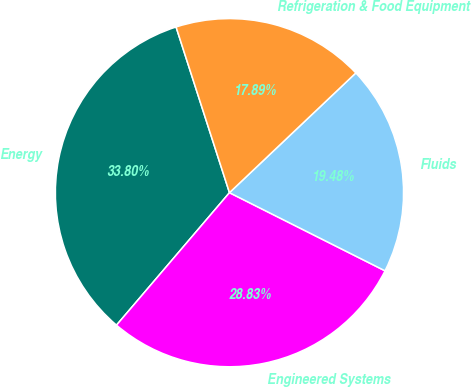<chart> <loc_0><loc_0><loc_500><loc_500><pie_chart><fcel>Energy<fcel>Engineered Systems<fcel>Fluids<fcel>Refrigeration & Food Equipment<nl><fcel>33.8%<fcel>28.83%<fcel>19.48%<fcel>17.89%<nl></chart> 